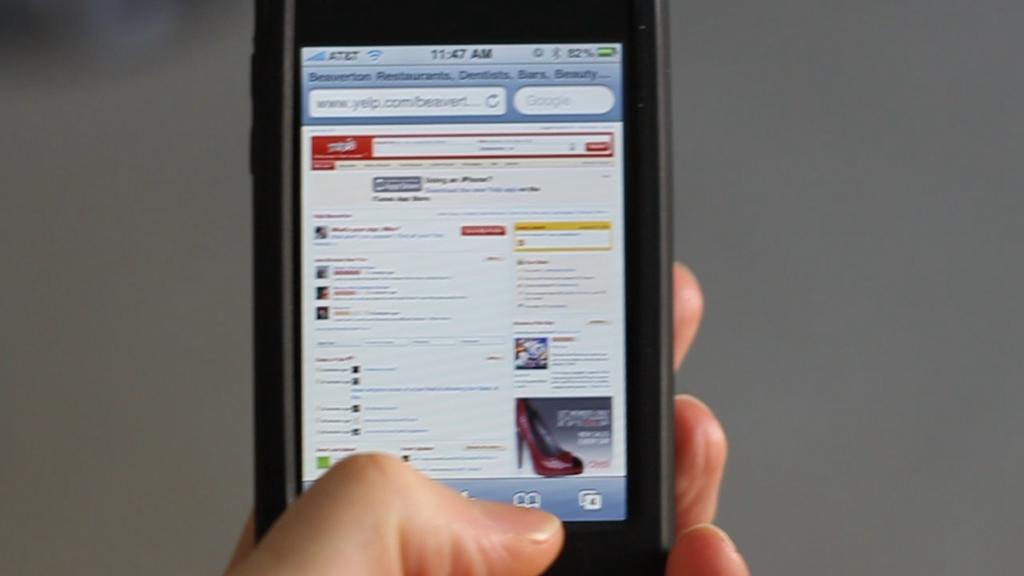What is the main subject of the image? There is a person in the center of the image. What is the person holding in the image? The person is holding a mobile phone. What can be seen on the mobile phone's screen? There is text visible on the mobile phone's screen, and there is an image of footwear. Can you describe the background of the image? The background of the image is blurry. What type of skin is visible on the person's back in the image? There is no visible skin or back of the person in the image, as the person is holding a mobile phone that covers most of their body. 